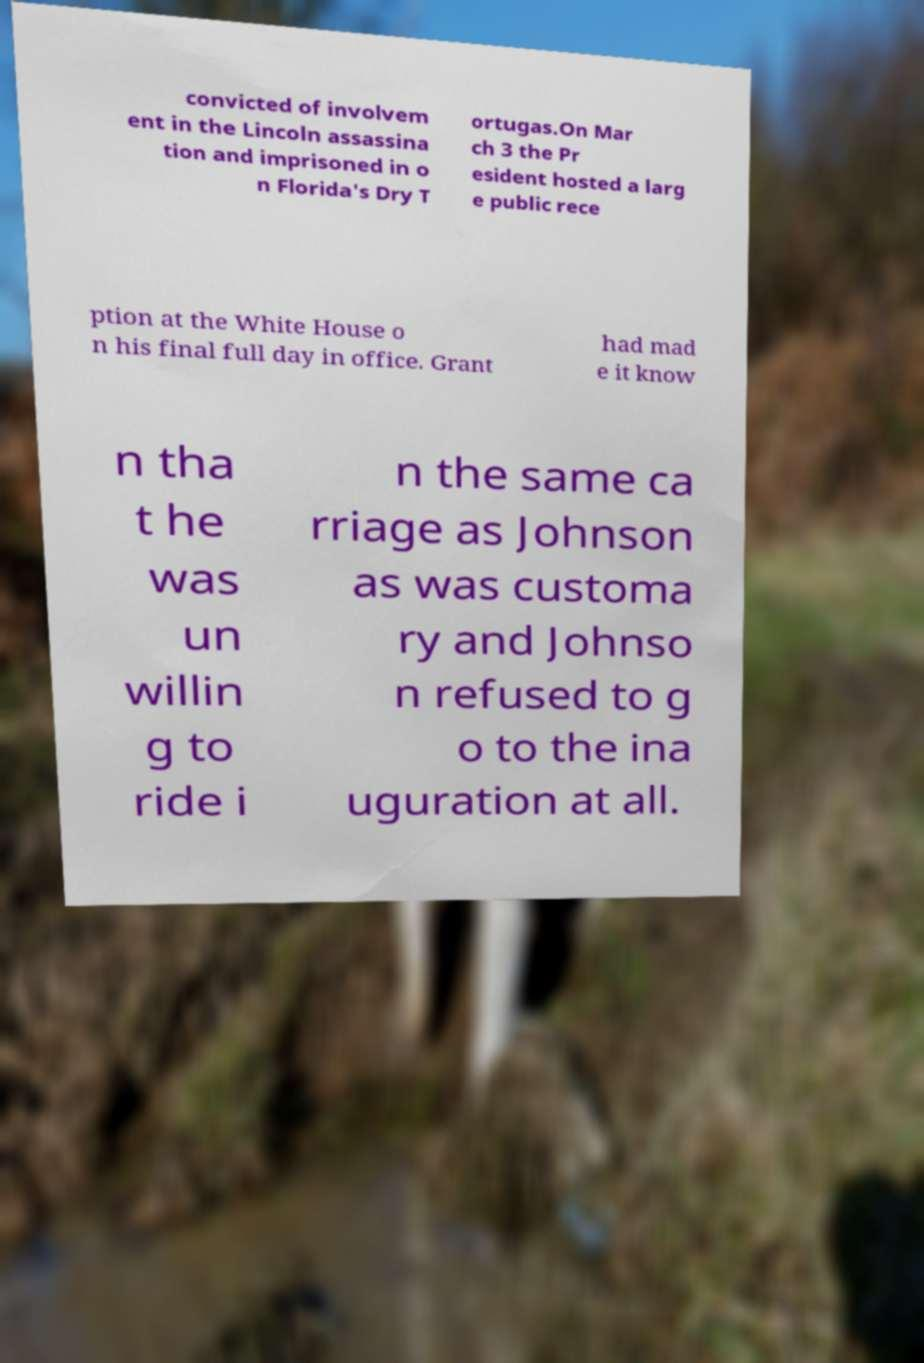There's text embedded in this image that I need extracted. Can you transcribe it verbatim? convicted of involvem ent in the Lincoln assassina tion and imprisoned in o n Florida's Dry T ortugas.On Mar ch 3 the Pr esident hosted a larg e public rece ption at the White House o n his final full day in office. Grant had mad e it know n tha t he was un willin g to ride i n the same ca rriage as Johnson as was customa ry and Johnso n refused to g o to the ina uguration at all. 